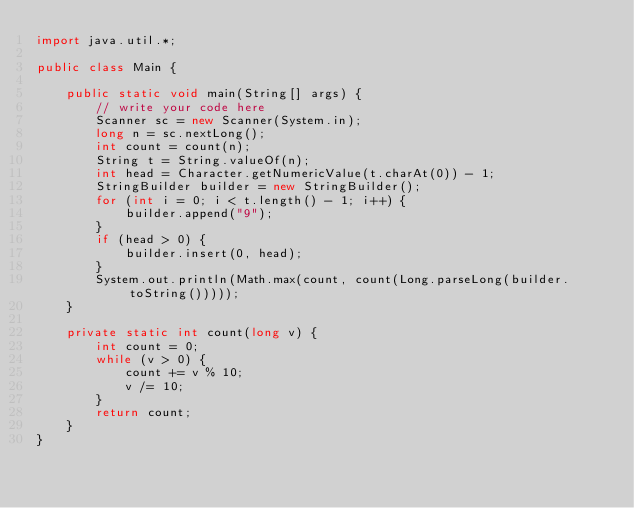Convert code to text. <code><loc_0><loc_0><loc_500><loc_500><_Java_>import java.util.*;

public class Main {

    public static void main(String[] args) {
        // write your code here
        Scanner sc = new Scanner(System.in);
        long n = sc.nextLong();
        int count = count(n);
        String t = String.valueOf(n);
        int head = Character.getNumericValue(t.charAt(0)) - 1;
        StringBuilder builder = new StringBuilder();
        for (int i = 0; i < t.length() - 1; i++) {
            builder.append("9");
        }
        if (head > 0) {
            builder.insert(0, head);
        }
        System.out.println(Math.max(count, count(Long.parseLong(builder.toString()))));
    }

    private static int count(long v) {
        int count = 0;
        while (v > 0) {
            count += v % 10;
            v /= 10;
        }
        return count;
    }
}</code> 